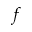<formula> <loc_0><loc_0><loc_500><loc_500>f</formula> 